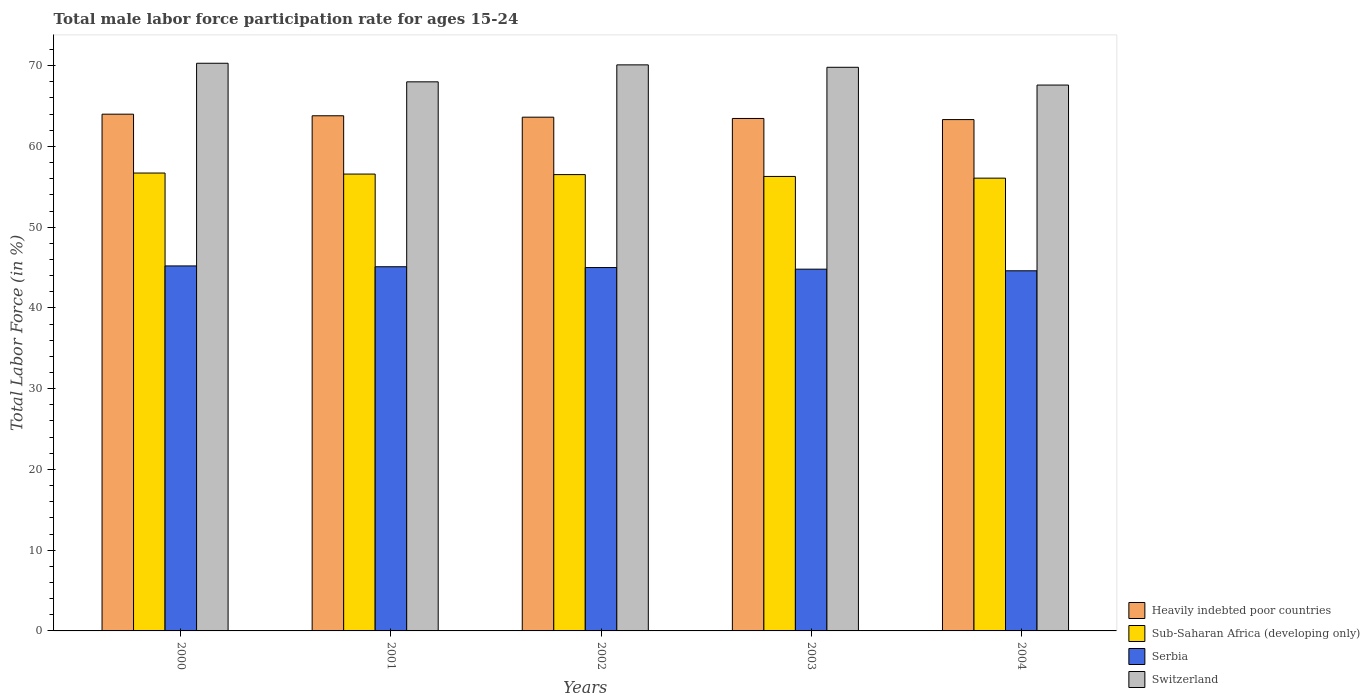How many different coloured bars are there?
Offer a terse response. 4. How many groups of bars are there?
Your response must be concise. 5. Are the number of bars on each tick of the X-axis equal?
Give a very brief answer. Yes. What is the male labor force participation rate in Sub-Saharan Africa (developing only) in 2003?
Make the answer very short. 56.28. Across all years, what is the maximum male labor force participation rate in Switzerland?
Ensure brevity in your answer.  70.3. Across all years, what is the minimum male labor force participation rate in Serbia?
Your answer should be compact. 44.6. In which year was the male labor force participation rate in Sub-Saharan Africa (developing only) maximum?
Make the answer very short. 2000. What is the total male labor force participation rate in Switzerland in the graph?
Your response must be concise. 345.8. What is the difference between the male labor force participation rate in Heavily indebted poor countries in 2001 and that in 2003?
Your answer should be very brief. 0.33. What is the difference between the male labor force participation rate in Heavily indebted poor countries in 2003 and the male labor force participation rate in Switzerland in 2002?
Offer a terse response. -6.64. What is the average male labor force participation rate in Heavily indebted poor countries per year?
Ensure brevity in your answer.  63.64. In the year 2000, what is the difference between the male labor force participation rate in Serbia and male labor force participation rate in Heavily indebted poor countries?
Your response must be concise. -18.79. What is the ratio of the male labor force participation rate in Sub-Saharan Africa (developing only) in 2000 to that in 2004?
Offer a very short reply. 1.01. Is the male labor force participation rate in Switzerland in 2001 less than that in 2003?
Ensure brevity in your answer.  Yes. Is the difference between the male labor force participation rate in Serbia in 2000 and 2003 greater than the difference between the male labor force participation rate in Heavily indebted poor countries in 2000 and 2003?
Make the answer very short. No. What is the difference between the highest and the second highest male labor force participation rate in Switzerland?
Your answer should be compact. 0.2. What is the difference between the highest and the lowest male labor force participation rate in Sub-Saharan Africa (developing only)?
Your answer should be compact. 0.63. Is it the case that in every year, the sum of the male labor force participation rate in Heavily indebted poor countries and male labor force participation rate in Sub-Saharan Africa (developing only) is greater than the sum of male labor force participation rate in Switzerland and male labor force participation rate in Serbia?
Your response must be concise. No. What does the 1st bar from the left in 2001 represents?
Make the answer very short. Heavily indebted poor countries. What does the 4th bar from the right in 2004 represents?
Offer a terse response. Heavily indebted poor countries. Is it the case that in every year, the sum of the male labor force participation rate in Heavily indebted poor countries and male labor force participation rate in Serbia is greater than the male labor force participation rate in Sub-Saharan Africa (developing only)?
Your response must be concise. Yes. Are the values on the major ticks of Y-axis written in scientific E-notation?
Your response must be concise. No. Does the graph contain grids?
Make the answer very short. No. How many legend labels are there?
Ensure brevity in your answer.  4. What is the title of the graph?
Your answer should be very brief. Total male labor force participation rate for ages 15-24. Does "East Asia (developing only)" appear as one of the legend labels in the graph?
Ensure brevity in your answer.  No. What is the label or title of the Y-axis?
Your answer should be very brief. Total Labor Force (in %). What is the Total Labor Force (in %) of Heavily indebted poor countries in 2000?
Offer a terse response. 63.99. What is the Total Labor Force (in %) in Sub-Saharan Africa (developing only) in 2000?
Ensure brevity in your answer.  56.7. What is the Total Labor Force (in %) in Serbia in 2000?
Your answer should be very brief. 45.2. What is the Total Labor Force (in %) of Switzerland in 2000?
Provide a succinct answer. 70.3. What is the Total Labor Force (in %) of Heavily indebted poor countries in 2001?
Offer a terse response. 63.8. What is the Total Labor Force (in %) of Sub-Saharan Africa (developing only) in 2001?
Provide a succinct answer. 56.58. What is the Total Labor Force (in %) of Serbia in 2001?
Your response must be concise. 45.1. What is the Total Labor Force (in %) in Switzerland in 2001?
Provide a short and direct response. 68. What is the Total Labor Force (in %) in Heavily indebted poor countries in 2002?
Ensure brevity in your answer.  63.62. What is the Total Labor Force (in %) of Sub-Saharan Africa (developing only) in 2002?
Make the answer very short. 56.51. What is the Total Labor Force (in %) in Switzerland in 2002?
Your answer should be compact. 70.1. What is the Total Labor Force (in %) of Heavily indebted poor countries in 2003?
Provide a short and direct response. 63.46. What is the Total Labor Force (in %) in Sub-Saharan Africa (developing only) in 2003?
Provide a short and direct response. 56.28. What is the Total Labor Force (in %) of Serbia in 2003?
Offer a very short reply. 44.8. What is the Total Labor Force (in %) of Switzerland in 2003?
Give a very brief answer. 69.8. What is the Total Labor Force (in %) of Heavily indebted poor countries in 2004?
Provide a short and direct response. 63.32. What is the Total Labor Force (in %) of Sub-Saharan Africa (developing only) in 2004?
Offer a terse response. 56.07. What is the Total Labor Force (in %) in Serbia in 2004?
Provide a short and direct response. 44.6. What is the Total Labor Force (in %) of Switzerland in 2004?
Give a very brief answer. 67.6. Across all years, what is the maximum Total Labor Force (in %) in Heavily indebted poor countries?
Your answer should be compact. 63.99. Across all years, what is the maximum Total Labor Force (in %) in Sub-Saharan Africa (developing only)?
Your answer should be very brief. 56.7. Across all years, what is the maximum Total Labor Force (in %) in Serbia?
Give a very brief answer. 45.2. Across all years, what is the maximum Total Labor Force (in %) of Switzerland?
Your answer should be very brief. 70.3. Across all years, what is the minimum Total Labor Force (in %) in Heavily indebted poor countries?
Keep it short and to the point. 63.32. Across all years, what is the minimum Total Labor Force (in %) of Sub-Saharan Africa (developing only)?
Provide a succinct answer. 56.07. Across all years, what is the minimum Total Labor Force (in %) of Serbia?
Give a very brief answer. 44.6. Across all years, what is the minimum Total Labor Force (in %) of Switzerland?
Make the answer very short. 67.6. What is the total Total Labor Force (in %) in Heavily indebted poor countries in the graph?
Your response must be concise. 318.2. What is the total Total Labor Force (in %) in Sub-Saharan Africa (developing only) in the graph?
Provide a succinct answer. 282.15. What is the total Total Labor Force (in %) in Serbia in the graph?
Provide a short and direct response. 224.7. What is the total Total Labor Force (in %) of Switzerland in the graph?
Offer a terse response. 345.8. What is the difference between the Total Labor Force (in %) of Heavily indebted poor countries in 2000 and that in 2001?
Ensure brevity in your answer.  0.2. What is the difference between the Total Labor Force (in %) in Sub-Saharan Africa (developing only) in 2000 and that in 2001?
Make the answer very short. 0.13. What is the difference between the Total Labor Force (in %) in Serbia in 2000 and that in 2001?
Keep it short and to the point. 0.1. What is the difference between the Total Labor Force (in %) in Switzerland in 2000 and that in 2001?
Provide a short and direct response. 2.3. What is the difference between the Total Labor Force (in %) of Heavily indebted poor countries in 2000 and that in 2002?
Keep it short and to the point. 0.37. What is the difference between the Total Labor Force (in %) in Sub-Saharan Africa (developing only) in 2000 and that in 2002?
Ensure brevity in your answer.  0.19. What is the difference between the Total Labor Force (in %) of Switzerland in 2000 and that in 2002?
Your answer should be compact. 0.2. What is the difference between the Total Labor Force (in %) of Heavily indebted poor countries in 2000 and that in 2003?
Your answer should be compact. 0.53. What is the difference between the Total Labor Force (in %) of Sub-Saharan Africa (developing only) in 2000 and that in 2003?
Your answer should be compact. 0.42. What is the difference between the Total Labor Force (in %) of Heavily indebted poor countries in 2000 and that in 2004?
Make the answer very short. 0.67. What is the difference between the Total Labor Force (in %) in Sub-Saharan Africa (developing only) in 2000 and that in 2004?
Make the answer very short. 0.63. What is the difference between the Total Labor Force (in %) in Switzerland in 2000 and that in 2004?
Ensure brevity in your answer.  2.7. What is the difference between the Total Labor Force (in %) in Heavily indebted poor countries in 2001 and that in 2002?
Give a very brief answer. 0.17. What is the difference between the Total Labor Force (in %) in Sub-Saharan Africa (developing only) in 2001 and that in 2002?
Make the answer very short. 0.07. What is the difference between the Total Labor Force (in %) of Serbia in 2001 and that in 2002?
Your answer should be compact. 0.1. What is the difference between the Total Labor Force (in %) in Heavily indebted poor countries in 2001 and that in 2003?
Make the answer very short. 0.33. What is the difference between the Total Labor Force (in %) of Sub-Saharan Africa (developing only) in 2001 and that in 2003?
Provide a short and direct response. 0.29. What is the difference between the Total Labor Force (in %) of Heavily indebted poor countries in 2001 and that in 2004?
Provide a short and direct response. 0.47. What is the difference between the Total Labor Force (in %) of Sub-Saharan Africa (developing only) in 2001 and that in 2004?
Your response must be concise. 0.5. What is the difference between the Total Labor Force (in %) of Heavily indebted poor countries in 2002 and that in 2003?
Your answer should be very brief. 0.16. What is the difference between the Total Labor Force (in %) in Sub-Saharan Africa (developing only) in 2002 and that in 2003?
Provide a short and direct response. 0.23. What is the difference between the Total Labor Force (in %) of Serbia in 2002 and that in 2003?
Keep it short and to the point. 0.2. What is the difference between the Total Labor Force (in %) of Heavily indebted poor countries in 2002 and that in 2004?
Offer a terse response. 0.3. What is the difference between the Total Labor Force (in %) in Sub-Saharan Africa (developing only) in 2002 and that in 2004?
Provide a succinct answer. 0.44. What is the difference between the Total Labor Force (in %) in Heavily indebted poor countries in 2003 and that in 2004?
Your response must be concise. 0.14. What is the difference between the Total Labor Force (in %) in Sub-Saharan Africa (developing only) in 2003 and that in 2004?
Your answer should be compact. 0.21. What is the difference between the Total Labor Force (in %) of Serbia in 2003 and that in 2004?
Give a very brief answer. 0.2. What is the difference between the Total Labor Force (in %) in Heavily indebted poor countries in 2000 and the Total Labor Force (in %) in Sub-Saharan Africa (developing only) in 2001?
Make the answer very short. 7.42. What is the difference between the Total Labor Force (in %) in Heavily indebted poor countries in 2000 and the Total Labor Force (in %) in Serbia in 2001?
Your answer should be compact. 18.89. What is the difference between the Total Labor Force (in %) of Heavily indebted poor countries in 2000 and the Total Labor Force (in %) of Switzerland in 2001?
Offer a very short reply. -4.01. What is the difference between the Total Labor Force (in %) of Sub-Saharan Africa (developing only) in 2000 and the Total Labor Force (in %) of Serbia in 2001?
Provide a short and direct response. 11.6. What is the difference between the Total Labor Force (in %) in Sub-Saharan Africa (developing only) in 2000 and the Total Labor Force (in %) in Switzerland in 2001?
Your answer should be compact. -11.3. What is the difference between the Total Labor Force (in %) of Serbia in 2000 and the Total Labor Force (in %) of Switzerland in 2001?
Give a very brief answer. -22.8. What is the difference between the Total Labor Force (in %) in Heavily indebted poor countries in 2000 and the Total Labor Force (in %) in Sub-Saharan Africa (developing only) in 2002?
Offer a terse response. 7.48. What is the difference between the Total Labor Force (in %) in Heavily indebted poor countries in 2000 and the Total Labor Force (in %) in Serbia in 2002?
Ensure brevity in your answer.  18.99. What is the difference between the Total Labor Force (in %) of Heavily indebted poor countries in 2000 and the Total Labor Force (in %) of Switzerland in 2002?
Ensure brevity in your answer.  -6.11. What is the difference between the Total Labor Force (in %) of Sub-Saharan Africa (developing only) in 2000 and the Total Labor Force (in %) of Serbia in 2002?
Your response must be concise. 11.7. What is the difference between the Total Labor Force (in %) of Sub-Saharan Africa (developing only) in 2000 and the Total Labor Force (in %) of Switzerland in 2002?
Ensure brevity in your answer.  -13.4. What is the difference between the Total Labor Force (in %) of Serbia in 2000 and the Total Labor Force (in %) of Switzerland in 2002?
Provide a short and direct response. -24.9. What is the difference between the Total Labor Force (in %) of Heavily indebted poor countries in 2000 and the Total Labor Force (in %) of Sub-Saharan Africa (developing only) in 2003?
Provide a short and direct response. 7.71. What is the difference between the Total Labor Force (in %) in Heavily indebted poor countries in 2000 and the Total Labor Force (in %) in Serbia in 2003?
Ensure brevity in your answer.  19.19. What is the difference between the Total Labor Force (in %) of Heavily indebted poor countries in 2000 and the Total Labor Force (in %) of Switzerland in 2003?
Provide a short and direct response. -5.81. What is the difference between the Total Labor Force (in %) in Sub-Saharan Africa (developing only) in 2000 and the Total Labor Force (in %) in Serbia in 2003?
Your answer should be compact. 11.9. What is the difference between the Total Labor Force (in %) of Sub-Saharan Africa (developing only) in 2000 and the Total Labor Force (in %) of Switzerland in 2003?
Provide a short and direct response. -13.1. What is the difference between the Total Labor Force (in %) in Serbia in 2000 and the Total Labor Force (in %) in Switzerland in 2003?
Make the answer very short. -24.6. What is the difference between the Total Labor Force (in %) of Heavily indebted poor countries in 2000 and the Total Labor Force (in %) of Sub-Saharan Africa (developing only) in 2004?
Ensure brevity in your answer.  7.92. What is the difference between the Total Labor Force (in %) of Heavily indebted poor countries in 2000 and the Total Labor Force (in %) of Serbia in 2004?
Ensure brevity in your answer.  19.39. What is the difference between the Total Labor Force (in %) in Heavily indebted poor countries in 2000 and the Total Labor Force (in %) in Switzerland in 2004?
Offer a terse response. -3.61. What is the difference between the Total Labor Force (in %) in Sub-Saharan Africa (developing only) in 2000 and the Total Labor Force (in %) in Serbia in 2004?
Your answer should be compact. 12.1. What is the difference between the Total Labor Force (in %) of Sub-Saharan Africa (developing only) in 2000 and the Total Labor Force (in %) of Switzerland in 2004?
Give a very brief answer. -10.9. What is the difference between the Total Labor Force (in %) in Serbia in 2000 and the Total Labor Force (in %) in Switzerland in 2004?
Your response must be concise. -22.4. What is the difference between the Total Labor Force (in %) in Heavily indebted poor countries in 2001 and the Total Labor Force (in %) in Sub-Saharan Africa (developing only) in 2002?
Your answer should be compact. 7.29. What is the difference between the Total Labor Force (in %) in Heavily indebted poor countries in 2001 and the Total Labor Force (in %) in Serbia in 2002?
Ensure brevity in your answer.  18.8. What is the difference between the Total Labor Force (in %) in Heavily indebted poor countries in 2001 and the Total Labor Force (in %) in Switzerland in 2002?
Make the answer very short. -6.3. What is the difference between the Total Labor Force (in %) in Sub-Saharan Africa (developing only) in 2001 and the Total Labor Force (in %) in Serbia in 2002?
Your answer should be compact. 11.58. What is the difference between the Total Labor Force (in %) in Sub-Saharan Africa (developing only) in 2001 and the Total Labor Force (in %) in Switzerland in 2002?
Offer a terse response. -13.52. What is the difference between the Total Labor Force (in %) of Serbia in 2001 and the Total Labor Force (in %) of Switzerland in 2002?
Ensure brevity in your answer.  -25. What is the difference between the Total Labor Force (in %) in Heavily indebted poor countries in 2001 and the Total Labor Force (in %) in Sub-Saharan Africa (developing only) in 2003?
Your answer should be compact. 7.51. What is the difference between the Total Labor Force (in %) of Heavily indebted poor countries in 2001 and the Total Labor Force (in %) of Serbia in 2003?
Your response must be concise. 19. What is the difference between the Total Labor Force (in %) of Heavily indebted poor countries in 2001 and the Total Labor Force (in %) of Switzerland in 2003?
Offer a terse response. -6. What is the difference between the Total Labor Force (in %) in Sub-Saharan Africa (developing only) in 2001 and the Total Labor Force (in %) in Serbia in 2003?
Provide a short and direct response. 11.78. What is the difference between the Total Labor Force (in %) of Sub-Saharan Africa (developing only) in 2001 and the Total Labor Force (in %) of Switzerland in 2003?
Offer a terse response. -13.22. What is the difference between the Total Labor Force (in %) in Serbia in 2001 and the Total Labor Force (in %) in Switzerland in 2003?
Offer a very short reply. -24.7. What is the difference between the Total Labor Force (in %) in Heavily indebted poor countries in 2001 and the Total Labor Force (in %) in Sub-Saharan Africa (developing only) in 2004?
Your answer should be very brief. 7.72. What is the difference between the Total Labor Force (in %) of Heavily indebted poor countries in 2001 and the Total Labor Force (in %) of Serbia in 2004?
Give a very brief answer. 19.2. What is the difference between the Total Labor Force (in %) in Heavily indebted poor countries in 2001 and the Total Labor Force (in %) in Switzerland in 2004?
Keep it short and to the point. -3.8. What is the difference between the Total Labor Force (in %) of Sub-Saharan Africa (developing only) in 2001 and the Total Labor Force (in %) of Serbia in 2004?
Your answer should be very brief. 11.98. What is the difference between the Total Labor Force (in %) in Sub-Saharan Africa (developing only) in 2001 and the Total Labor Force (in %) in Switzerland in 2004?
Ensure brevity in your answer.  -11.02. What is the difference between the Total Labor Force (in %) in Serbia in 2001 and the Total Labor Force (in %) in Switzerland in 2004?
Make the answer very short. -22.5. What is the difference between the Total Labor Force (in %) in Heavily indebted poor countries in 2002 and the Total Labor Force (in %) in Sub-Saharan Africa (developing only) in 2003?
Keep it short and to the point. 7.34. What is the difference between the Total Labor Force (in %) of Heavily indebted poor countries in 2002 and the Total Labor Force (in %) of Serbia in 2003?
Provide a short and direct response. 18.82. What is the difference between the Total Labor Force (in %) of Heavily indebted poor countries in 2002 and the Total Labor Force (in %) of Switzerland in 2003?
Give a very brief answer. -6.18. What is the difference between the Total Labor Force (in %) of Sub-Saharan Africa (developing only) in 2002 and the Total Labor Force (in %) of Serbia in 2003?
Provide a succinct answer. 11.71. What is the difference between the Total Labor Force (in %) in Sub-Saharan Africa (developing only) in 2002 and the Total Labor Force (in %) in Switzerland in 2003?
Make the answer very short. -13.29. What is the difference between the Total Labor Force (in %) of Serbia in 2002 and the Total Labor Force (in %) of Switzerland in 2003?
Make the answer very short. -24.8. What is the difference between the Total Labor Force (in %) of Heavily indebted poor countries in 2002 and the Total Labor Force (in %) of Sub-Saharan Africa (developing only) in 2004?
Make the answer very short. 7.55. What is the difference between the Total Labor Force (in %) in Heavily indebted poor countries in 2002 and the Total Labor Force (in %) in Serbia in 2004?
Make the answer very short. 19.02. What is the difference between the Total Labor Force (in %) in Heavily indebted poor countries in 2002 and the Total Labor Force (in %) in Switzerland in 2004?
Your answer should be compact. -3.98. What is the difference between the Total Labor Force (in %) in Sub-Saharan Africa (developing only) in 2002 and the Total Labor Force (in %) in Serbia in 2004?
Give a very brief answer. 11.91. What is the difference between the Total Labor Force (in %) in Sub-Saharan Africa (developing only) in 2002 and the Total Labor Force (in %) in Switzerland in 2004?
Your response must be concise. -11.09. What is the difference between the Total Labor Force (in %) of Serbia in 2002 and the Total Labor Force (in %) of Switzerland in 2004?
Give a very brief answer. -22.6. What is the difference between the Total Labor Force (in %) of Heavily indebted poor countries in 2003 and the Total Labor Force (in %) of Sub-Saharan Africa (developing only) in 2004?
Your answer should be compact. 7.39. What is the difference between the Total Labor Force (in %) of Heavily indebted poor countries in 2003 and the Total Labor Force (in %) of Serbia in 2004?
Provide a short and direct response. 18.86. What is the difference between the Total Labor Force (in %) of Heavily indebted poor countries in 2003 and the Total Labor Force (in %) of Switzerland in 2004?
Ensure brevity in your answer.  -4.14. What is the difference between the Total Labor Force (in %) in Sub-Saharan Africa (developing only) in 2003 and the Total Labor Force (in %) in Serbia in 2004?
Ensure brevity in your answer.  11.68. What is the difference between the Total Labor Force (in %) in Sub-Saharan Africa (developing only) in 2003 and the Total Labor Force (in %) in Switzerland in 2004?
Your response must be concise. -11.32. What is the difference between the Total Labor Force (in %) in Serbia in 2003 and the Total Labor Force (in %) in Switzerland in 2004?
Provide a succinct answer. -22.8. What is the average Total Labor Force (in %) in Heavily indebted poor countries per year?
Give a very brief answer. 63.64. What is the average Total Labor Force (in %) in Sub-Saharan Africa (developing only) per year?
Your answer should be very brief. 56.43. What is the average Total Labor Force (in %) in Serbia per year?
Provide a succinct answer. 44.94. What is the average Total Labor Force (in %) in Switzerland per year?
Your answer should be very brief. 69.16. In the year 2000, what is the difference between the Total Labor Force (in %) in Heavily indebted poor countries and Total Labor Force (in %) in Sub-Saharan Africa (developing only)?
Your answer should be compact. 7.29. In the year 2000, what is the difference between the Total Labor Force (in %) in Heavily indebted poor countries and Total Labor Force (in %) in Serbia?
Offer a terse response. 18.79. In the year 2000, what is the difference between the Total Labor Force (in %) of Heavily indebted poor countries and Total Labor Force (in %) of Switzerland?
Ensure brevity in your answer.  -6.31. In the year 2000, what is the difference between the Total Labor Force (in %) in Sub-Saharan Africa (developing only) and Total Labor Force (in %) in Serbia?
Your response must be concise. 11.5. In the year 2000, what is the difference between the Total Labor Force (in %) of Sub-Saharan Africa (developing only) and Total Labor Force (in %) of Switzerland?
Your response must be concise. -13.6. In the year 2000, what is the difference between the Total Labor Force (in %) in Serbia and Total Labor Force (in %) in Switzerland?
Offer a very short reply. -25.1. In the year 2001, what is the difference between the Total Labor Force (in %) in Heavily indebted poor countries and Total Labor Force (in %) in Sub-Saharan Africa (developing only)?
Keep it short and to the point. 7.22. In the year 2001, what is the difference between the Total Labor Force (in %) in Heavily indebted poor countries and Total Labor Force (in %) in Serbia?
Your answer should be compact. 18.7. In the year 2001, what is the difference between the Total Labor Force (in %) of Heavily indebted poor countries and Total Labor Force (in %) of Switzerland?
Your answer should be compact. -4.2. In the year 2001, what is the difference between the Total Labor Force (in %) of Sub-Saharan Africa (developing only) and Total Labor Force (in %) of Serbia?
Keep it short and to the point. 11.48. In the year 2001, what is the difference between the Total Labor Force (in %) of Sub-Saharan Africa (developing only) and Total Labor Force (in %) of Switzerland?
Your answer should be very brief. -11.42. In the year 2001, what is the difference between the Total Labor Force (in %) of Serbia and Total Labor Force (in %) of Switzerland?
Offer a terse response. -22.9. In the year 2002, what is the difference between the Total Labor Force (in %) of Heavily indebted poor countries and Total Labor Force (in %) of Sub-Saharan Africa (developing only)?
Ensure brevity in your answer.  7.11. In the year 2002, what is the difference between the Total Labor Force (in %) of Heavily indebted poor countries and Total Labor Force (in %) of Serbia?
Your response must be concise. 18.62. In the year 2002, what is the difference between the Total Labor Force (in %) in Heavily indebted poor countries and Total Labor Force (in %) in Switzerland?
Give a very brief answer. -6.48. In the year 2002, what is the difference between the Total Labor Force (in %) of Sub-Saharan Africa (developing only) and Total Labor Force (in %) of Serbia?
Provide a succinct answer. 11.51. In the year 2002, what is the difference between the Total Labor Force (in %) of Sub-Saharan Africa (developing only) and Total Labor Force (in %) of Switzerland?
Your response must be concise. -13.59. In the year 2002, what is the difference between the Total Labor Force (in %) in Serbia and Total Labor Force (in %) in Switzerland?
Your answer should be very brief. -25.1. In the year 2003, what is the difference between the Total Labor Force (in %) in Heavily indebted poor countries and Total Labor Force (in %) in Sub-Saharan Africa (developing only)?
Offer a very short reply. 7.18. In the year 2003, what is the difference between the Total Labor Force (in %) of Heavily indebted poor countries and Total Labor Force (in %) of Serbia?
Keep it short and to the point. 18.66. In the year 2003, what is the difference between the Total Labor Force (in %) in Heavily indebted poor countries and Total Labor Force (in %) in Switzerland?
Provide a succinct answer. -6.34. In the year 2003, what is the difference between the Total Labor Force (in %) in Sub-Saharan Africa (developing only) and Total Labor Force (in %) in Serbia?
Make the answer very short. 11.48. In the year 2003, what is the difference between the Total Labor Force (in %) in Sub-Saharan Africa (developing only) and Total Labor Force (in %) in Switzerland?
Your answer should be very brief. -13.52. In the year 2003, what is the difference between the Total Labor Force (in %) of Serbia and Total Labor Force (in %) of Switzerland?
Your answer should be very brief. -25. In the year 2004, what is the difference between the Total Labor Force (in %) of Heavily indebted poor countries and Total Labor Force (in %) of Sub-Saharan Africa (developing only)?
Your response must be concise. 7.25. In the year 2004, what is the difference between the Total Labor Force (in %) of Heavily indebted poor countries and Total Labor Force (in %) of Serbia?
Keep it short and to the point. 18.72. In the year 2004, what is the difference between the Total Labor Force (in %) of Heavily indebted poor countries and Total Labor Force (in %) of Switzerland?
Give a very brief answer. -4.28. In the year 2004, what is the difference between the Total Labor Force (in %) in Sub-Saharan Africa (developing only) and Total Labor Force (in %) in Serbia?
Your answer should be compact. 11.47. In the year 2004, what is the difference between the Total Labor Force (in %) of Sub-Saharan Africa (developing only) and Total Labor Force (in %) of Switzerland?
Provide a short and direct response. -11.53. In the year 2004, what is the difference between the Total Labor Force (in %) in Serbia and Total Labor Force (in %) in Switzerland?
Provide a short and direct response. -23. What is the ratio of the Total Labor Force (in %) of Sub-Saharan Africa (developing only) in 2000 to that in 2001?
Give a very brief answer. 1. What is the ratio of the Total Labor Force (in %) of Switzerland in 2000 to that in 2001?
Keep it short and to the point. 1.03. What is the ratio of the Total Labor Force (in %) in Heavily indebted poor countries in 2000 to that in 2002?
Your response must be concise. 1.01. What is the ratio of the Total Labor Force (in %) of Sub-Saharan Africa (developing only) in 2000 to that in 2002?
Your response must be concise. 1. What is the ratio of the Total Labor Force (in %) in Serbia in 2000 to that in 2002?
Ensure brevity in your answer.  1. What is the ratio of the Total Labor Force (in %) of Heavily indebted poor countries in 2000 to that in 2003?
Your response must be concise. 1.01. What is the ratio of the Total Labor Force (in %) of Sub-Saharan Africa (developing only) in 2000 to that in 2003?
Offer a terse response. 1.01. What is the ratio of the Total Labor Force (in %) of Serbia in 2000 to that in 2003?
Make the answer very short. 1.01. What is the ratio of the Total Labor Force (in %) in Heavily indebted poor countries in 2000 to that in 2004?
Your answer should be very brief. 1.01. What is the ratio of the Total Labor Force (in %) in Sub-Saharan Africa (developing only) in 2000 to that in 2004?
Keep it short and to the point. 1.01. What is the ratio of the Total Labor Force (in %) in Serbia in 2000 to that in 2004?
Ensure brevity in your answer.  1.01. What is the ratio of the Total Labor Force (in %) in Switzerland in 2000 to that in 2004?
Make the answer very short. 1.04. What is the ratio of the Total Labor Force (in %) in Heavily indebted poor countries in 2001 to that in 2003?
Offer a very short reply. 1.01. What is the ratio of the Total Labor Force (in %) of Serbia in 2001 to that in 2003?
Your answer should be compact. 1.01. What is the ratio of the Total Labor Force (in %) in Switzerland in 2001 to that in 2003?
Provide a succinct answer. 0.97. What is the ratio of the Total Labor Force (in %) in Heavily indebted poor countries in 2001 to that in 2004?
Your answer should be very brief. 1.01. What is the ratio of the Total Labor Force (in %) of Sub-Saharan Africa (developing only) in 2001 to that in 2004?
Offer a very short reply. 1.01. What is the ratio of the Total Labor Force (in %) in Serbia in 2001 to that in 2004?
Provide a short and direct response. 1.01. What is the ratio of the Total Labor Force (in %) of Switzerland in 2001 to that in 2004?
Offer a very short reply. 1.01. What is the ratio of the Total Labor Force (in %) of Sub-Saharan Africa (developing only) in 2002 to that in 2003?
Your response must be concise. 1. What is the ratio of the Total Labor Force (in %) of Serbia in 2002 to that in 2003?
Your answer should be compact. 1. What is the ratio of the Total Labor Force (in %) in Sub-Saharan Africa (developing only) in 2002 to that in 2004?
Offer a terse response. 1.01. What is the ratio of the Total Labor Force (in %) in Serbia in 2002 to that in 2004?
Offer a terse response. 1.01. What is the ratio of the Total Labor Force (in %) in Switzerland in 2002 to that in 2004?
Your answer should be compact. 1.04. What is the ratio of the Total Labor Force (in %) in Heavily indebted poor countries in 2003 to that in 2004?
Give a very brief answer. 1. What is the ratio of the Total Labor Force (in %) of Sub-Saharan Africa (developing only) in 2003 to that in 2004?
Keep it short and to the point. 1. What is the ratio of the Total Labor Force (in %) of Serbia in 2003 to that in 2004?
Keep it short and to the point. 1. What is the ratio of the Total Labor Force (in %) of Switzerland in 2003 to that in 2004?
Offer a terse response. 1.03. What is the difference between the highest and the second highest Total Labor Force (in %) in Heavily indebted poor countries?
Offer a very short reply. 0.2. What is the difference between the highest and the second highest Total Labor Force (in %) in Sub-Saharan Africa (developing only)?
Keep it short and to the point. 0.13. What is the difference between the highest and the second highest Total Labor Force (in %) in Serbia?
Your answer should be compact. 0.1. What is the difference between the highest and the second highest Total Labor Force (in %) of Switzerland?
Provide a succinct answer. 0.2. What is the difference between the highest and the lowest Total Labor Force (in %) of Heavily indebted poor countries?
Offer a terse response. 0.67. What is the difference between the highest and the lowest Total Labor Force (in %) of Sub-Saharan Africa (developing only)?
Ensure brevity in your answer.  0.63. What is the difference between the highest and the lowest Total Labor Force (in %) in Serbia?
Provide a succinct answer. 0.6. 